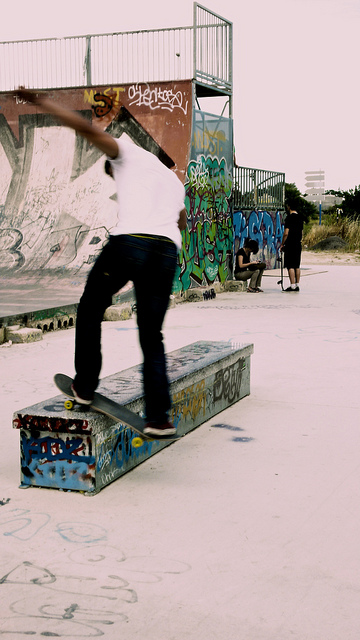Please extract the text content from this image. C MUST 